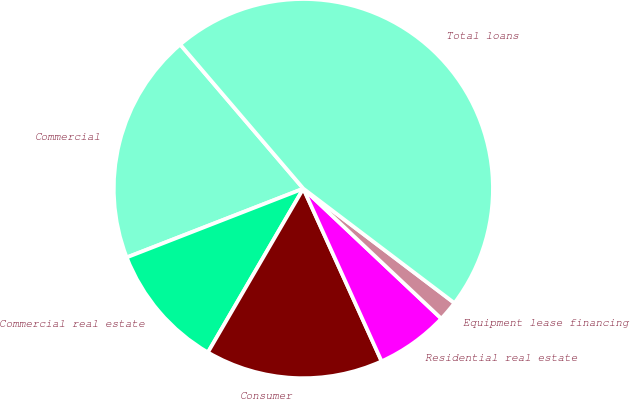Convert chart to OTSL. <chart><loc_0><loc_0><loc_500><loc_500><pie_chart><fcel>Commercial<fcel>Commercial real estate<fcel>Consumer<fcel>Residential real estate<fcel>Equipment lease financing<fcel>Total loans<nl><fcel>19.66%<fcel>10.69%<fcel>15.17%<fcel>6.2%<fcel>1.71%<fcel>46.57%<nl></chart> 